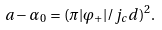<formula> <loc_0><loc_0><loc_500><loc_500>a - \alpha _ { 0 } = ( \pi | \varphi _ { + } | / j _ { c } d ) ^ { 2 } .</formula> 